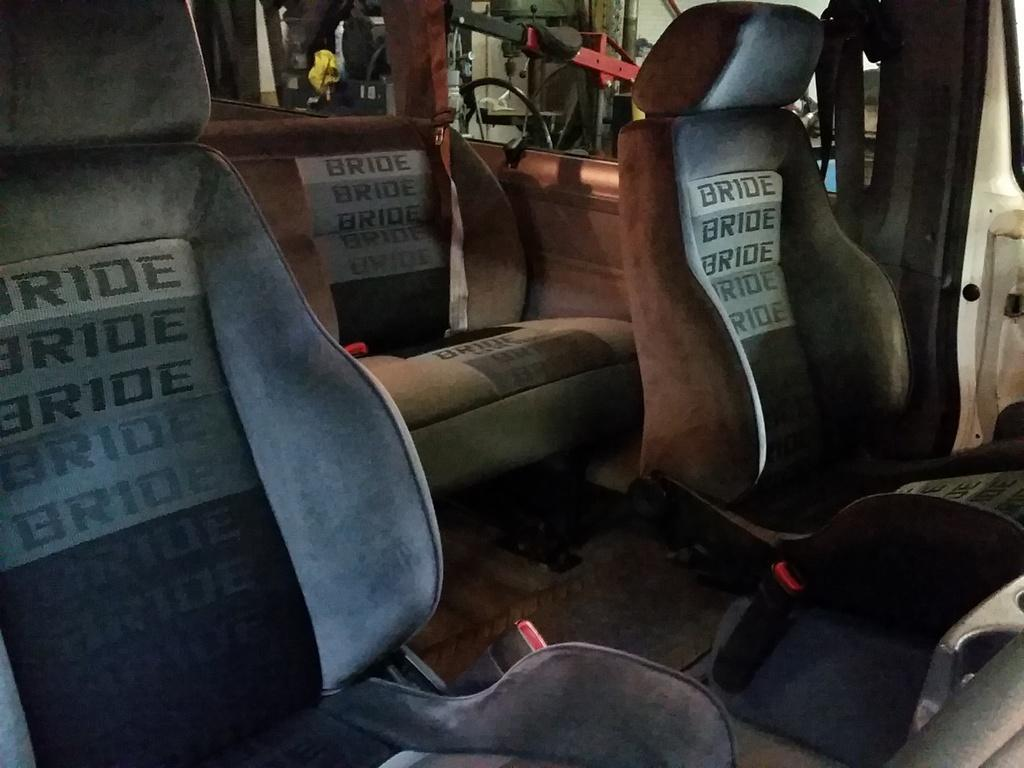Where was the image taken? The image was taken inside a vehicle. What can be found inside the vehicle? There are seats in the vehicle. What else can be seen in the image besides the seats? There are objects visible in the background of the image. Can you describe the seats in the image? The seats have text on them. How does the vehicle force people to sort their belongings in the image? The image does not show any sorting of belongings or any force being applied to people. 